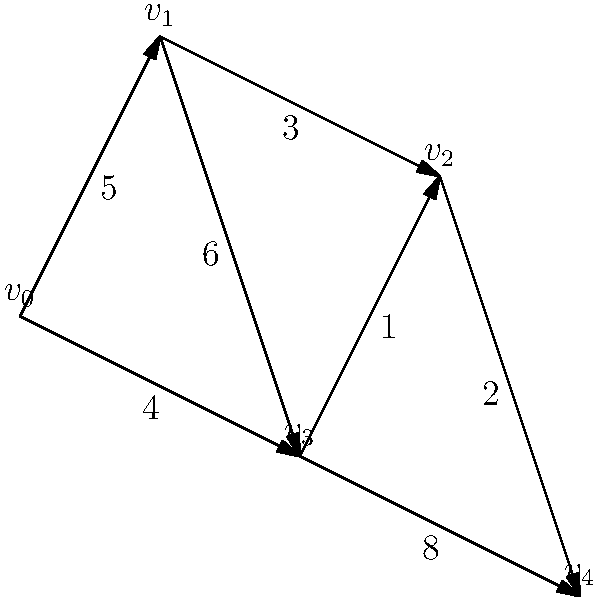A delivery truck needs to find the shortest route from vertex $v_0$ to vertex $v_4$ in the given road network. Each edge represents a road, and the number on each edge represents the distance in kilometers. What is the length of the shortest path from $v_0$ to $v_4$? To find the shortest path, we'll use Dijkstra's algorithm:

1) Initialize distances: $d(v_0) = 0$, $d(v_1) = \infty$, $d(v_2) = \infty$, $d(v_3) = \infty$, $d(v_4) = \infty$

2) Start from $v_0$:
   - Update $d(v_1) = 5$
   - Update $d(v_3) = 4$

3) Choose the vertex with the smallest distance (v_3):
   - Update $d(v_2) = 4 + 1 = 5$
   - Update $d(v_4) = 4 + 8 = 12$

4) Choose the next smallest distance (v_1):
   - $d(v_2)$ is already 5, no update needed
   - $d(v_3)$ is already 4, no update needed

5) Choose v_2:
   - Update $d(v_4) = \min(12, 5 + 2) = 7$

6) The algorithm terminates as we've reached v_4.

The shortest path is $v_0 \rightarrow v_3 \rightarrow v_2 \rightarrow v_4$ with a total length of 7 km.
Answer: 7 km 